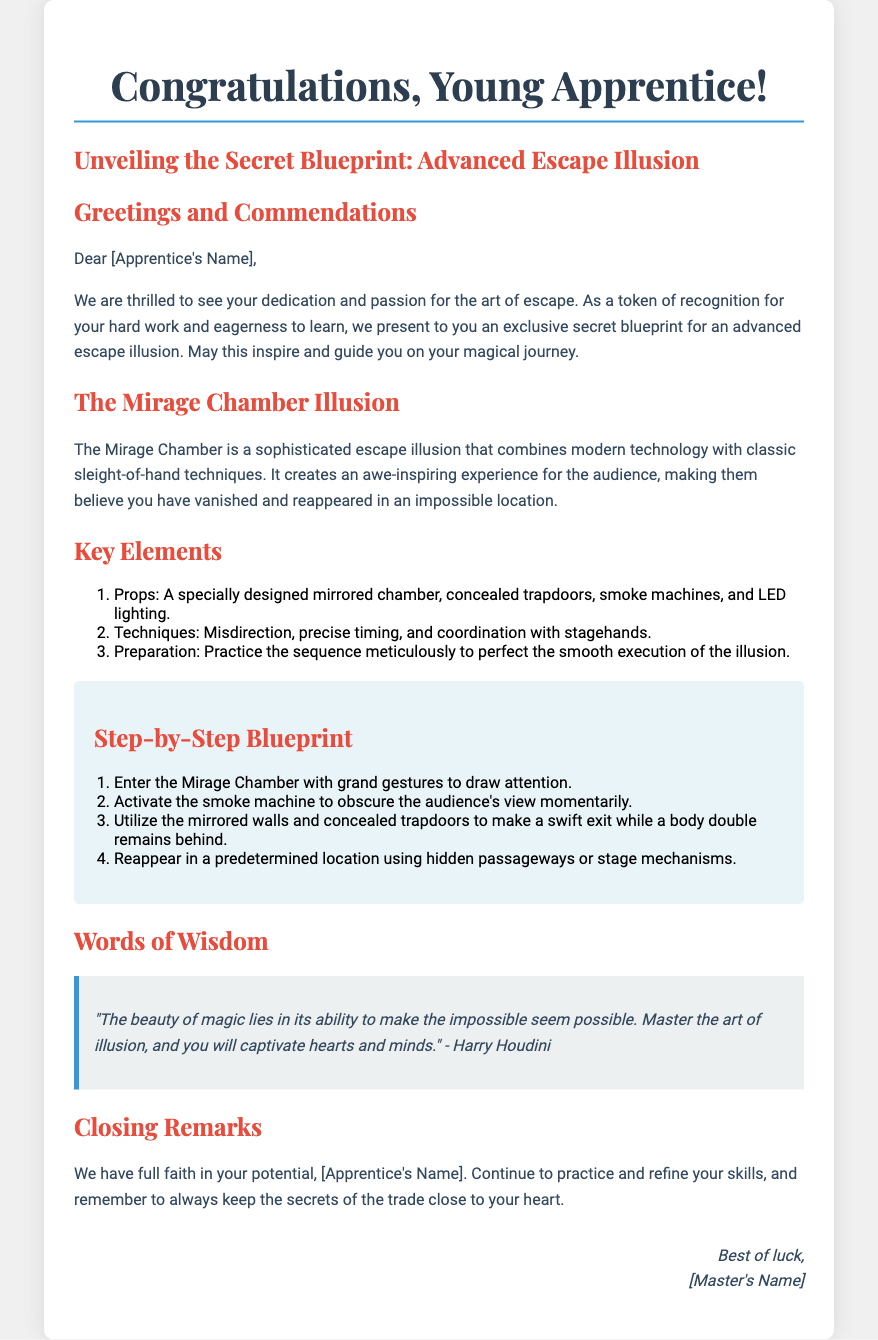What is the title of the card? The title of the card is prominently displayed at the top of the document.
Answer: Congratulations, Young Apprentice! Who is the recipient of the card? The card addresses a specific person, as indicated in the greeting section.
Answer: [Apprentice's Name] What is the name of the illusion discussed? The card specifically names the advanced escape illusion being unveiled.
Answer: The Mirage Chamber Illusion How many key elements are listed for the illusion? The document outlines a specific number of key elements related to the illusion.
Answer: Three What is the last quoted phrase in the card? The card includes a famous quote which is placed in a specific section.
Answer: "The beauty of magic lies in its ability to make the impossible seem possible." What is the first step in the blueprint? The document details the step-by-step process of the escape illusion, with a clear first step mentioned.
Answer: Enter the Mirage Chamber with grand gestures to draw attention Who is providing the card? The closing section of the card includes the name of the sender.
Answer: [Master's Name] What does the card encourage the apprentice to do? The overall intent of the card includes motivational advice to the apprentice.
Answer: Practice and refine skills 